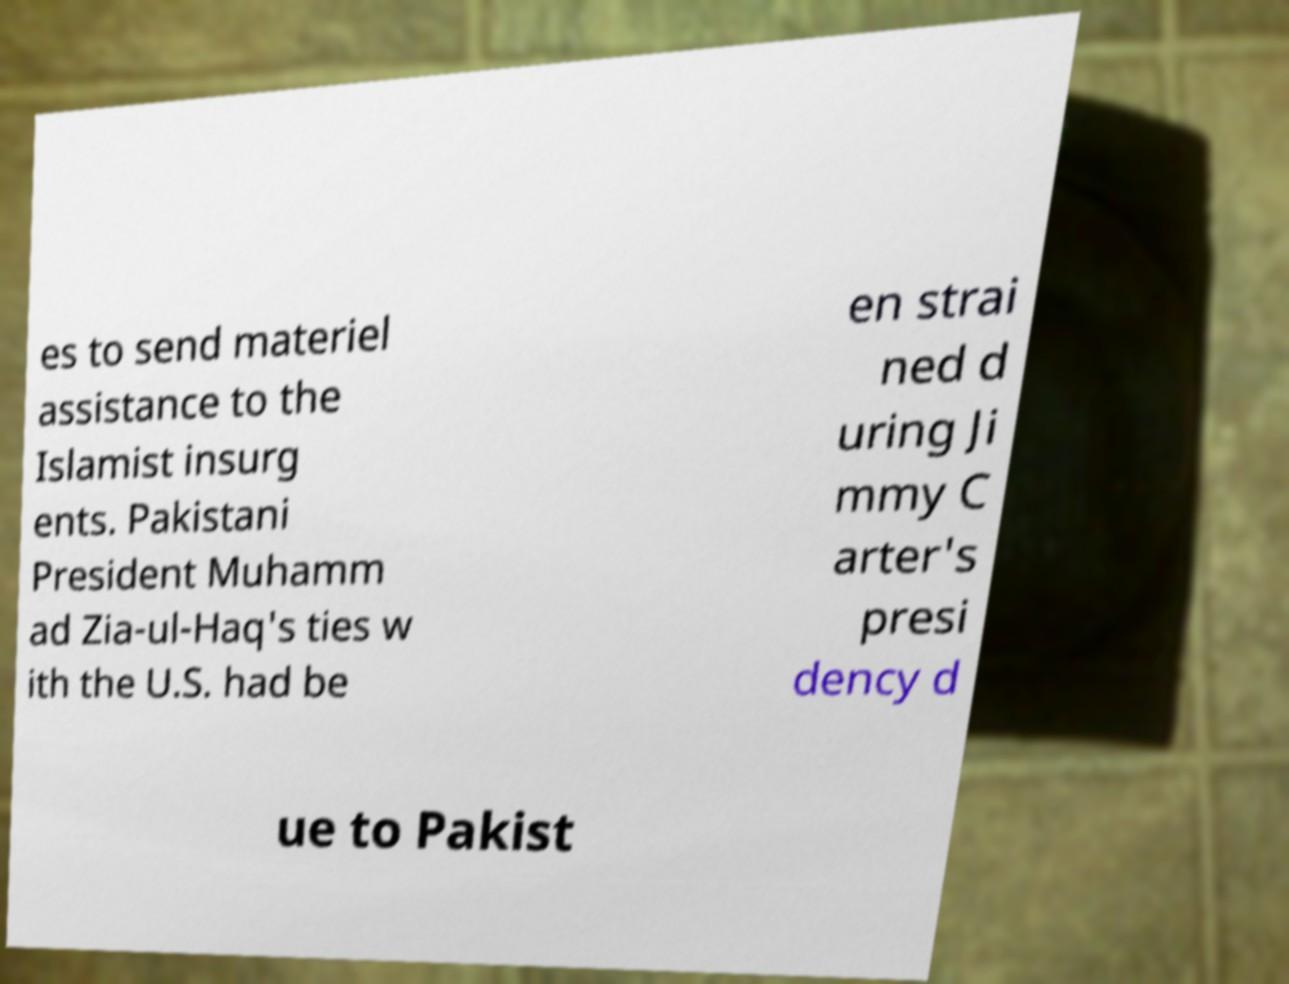Please read and relay the text visible in this image. What does it say? es to send materiel assistance to the Islamist insurg ents. Pakistani President Muhamm ad Zia-ul-Haq's ties w ith the U.S. had be en strai ned d uring Ji mmy C arter's presi dency d ue to Pakist 